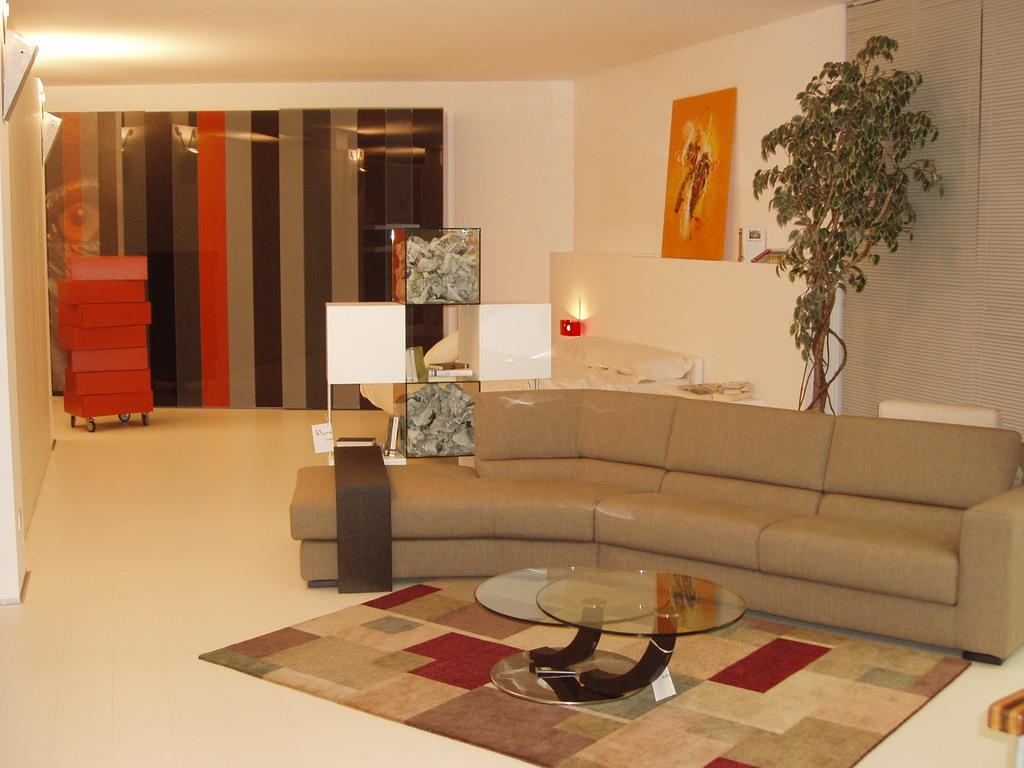What type of furniture is in the image? There is a sofa in the image. What is in front of the sofa? There is a glass table in front of the sofa. What can be seen behind the sofa? There is a tree behind the sofa. What color is the background wall in the image? The background wall is white in color. How many sofas are being pushed in the image? There is no indication of any sofas being pushed in the image. 